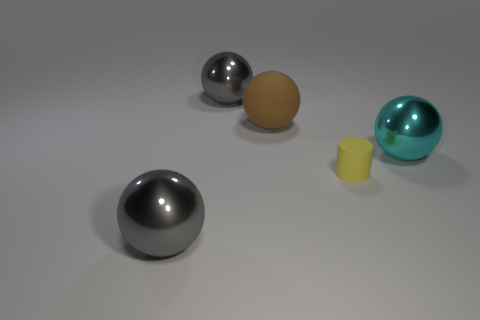There is a tiny cylinder; are there any small yellow objects in front of it?
Your response must be concise. No. What number of other objects are there of the same shape as the cyan metallic object?
Offer a very short reply. 3. The matte sphere that is the same size as the cyan metal object is what color?
Make the answer very short. Brown. Are there fewer large brown rubber things that are in front of the brown matte object than big balls that are on the right side of the big cyan metallic sphere?
Offer a very short reply. No. There is a big gray metal ball behind the gray metallic thing in front of the big matte object; how many metallic spheres are in front of it?
Your answer should be compact. 2. There is a brown object that is the same shape as the cyan shiny thing; what size is it?
Offer a very short reply. Large. Is there anything else that is the same size as the matte sphere?
Provide a short and direct response. Yes. Is the number of gray metallic balls that are behind the brown rubber thing less than the number of small yellow rubber objects?
Your response must be concise. No. Is the shape of the cyan thing the same as the yellow rubber object?
Ensure brevity in your answer.  No. There is another big matte thing that is the same shape as the large cyan object; what color is it?
Make the answer very short. Brown. 